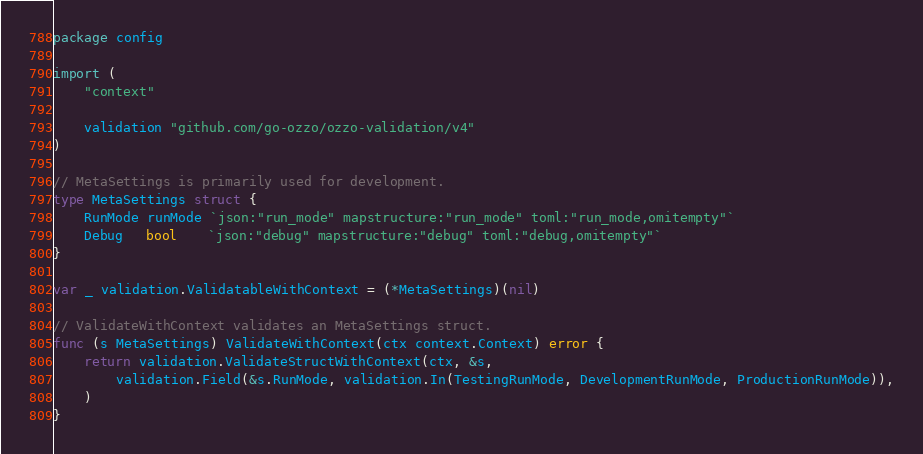Convert code to text. <code><loc_0><loc_0><loc_500><loc_500><_Go_>package config

import (
	"context"

	validation "github.com/go-ozzo/ozzo-validation/v4"
)

// MetaSettings is primarily used for development.
type MetaSettings struct {
	RunMode runMode `json:"run_mode" mapstructure:"run_mode" toml:"run_mode,omitempty"`
	Debug   bool    `json:"debug" mapstructure:"debug" toml:"debug,omitempty"`
}

var _ validation.ValidatableWithContext = (*MetaSettings)(nil)

// ValidateWithContext validates an MetaSettings struct.
func (s MetaSettings) ValidateWithContext(ctx context.Context) error {
	return validation.ValidateStructWithContext(ctx, &s,
		validation.Field(&s.RunMode, validation.In(TestingRunMode, DevelopmentRunMode, ProductionRunMode)),
	)
}
</code> 